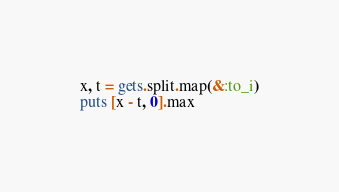<code> <loc_0><loc_0><loc_500><loc_500><_Ruby_>x, t = gets.split.map(&:to_i)
puts [x - t, 0].max
</code> 